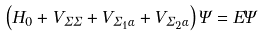Convert formula to latex. <formula><loc_0><loc_0><loc_500><loc_500>\left ( H _ { 0 } + V _ { \Sigma \Sigma } + V _ { \Sigma _ { 1 } \alpha } + V _ { \Sigma _ { 2 } \alpha } \right ) \Psi = E \Psi</formula> 